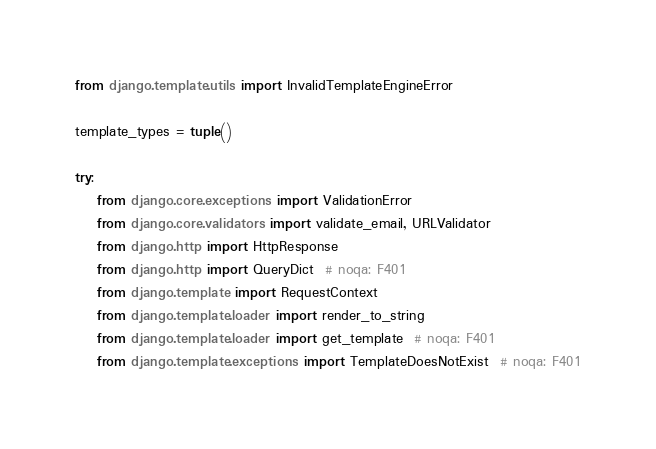Convert code to text. <code><loc_0><loc_0><loc_500><loc_500><_Python_>from django.template.utils import InvalidTemplateEngineError

template_types = tuple()

try:
    from django.core.exceptions import ValidationError
    from django.core.validators import validate_email, URLValidator
    from django.http import HttpResponse
    from django.http import QueryDict  # noqa: F401
    from django.template import RequestContext
    from django.template.loader import render_to_string
    from django.template.loader import get_template  # noqa: F401
    from django.template.exceptions import TemplateDoesNotExist  # noqa: F401</code> 